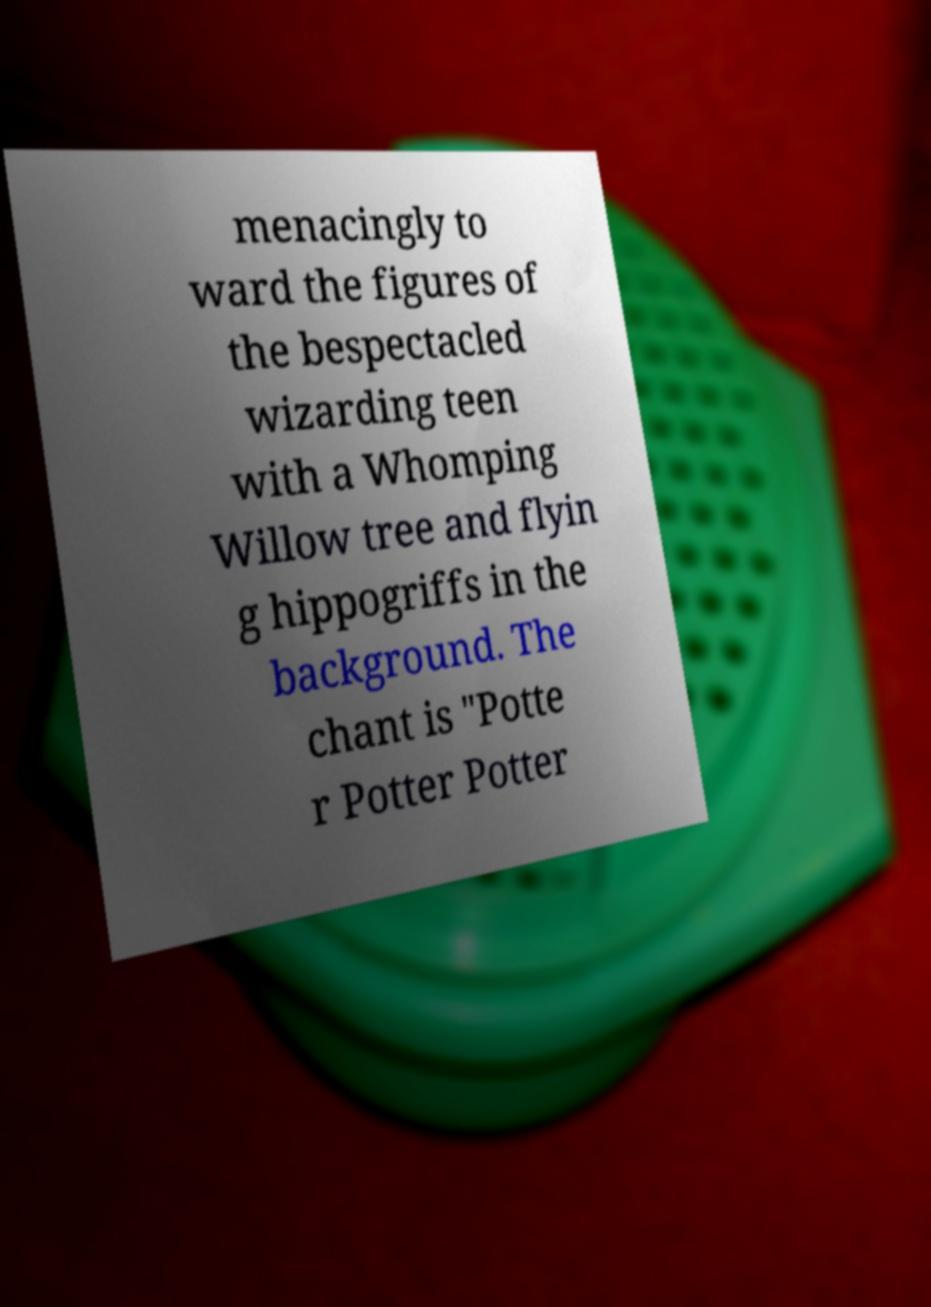For documentation purposes, I need the text within this image transcribed. Could you provide that? menacingly to ward the figures of the bespectacled wizarding teen with a Whomping Willow tree and flyin g hippogriffs in the background. The chant is "Potte r Potter Potter 